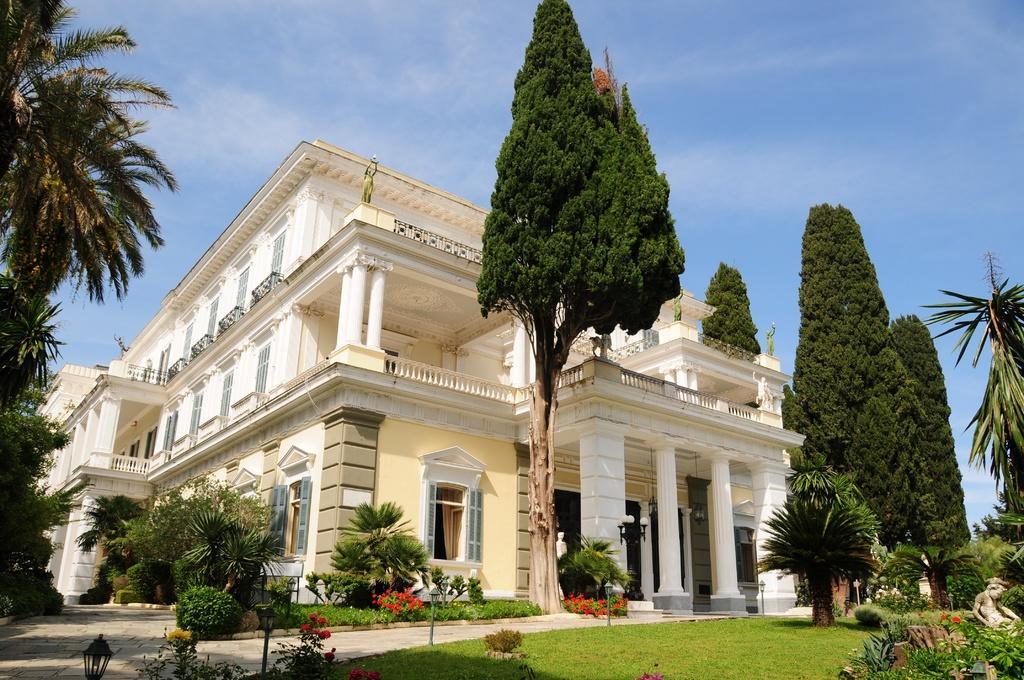Could you give a brief overview of what you see in this image? In this picture we can see a building, in front of the building we can find few trees, plants, flowers, grass and few metal rods, and also we can see few lights. 